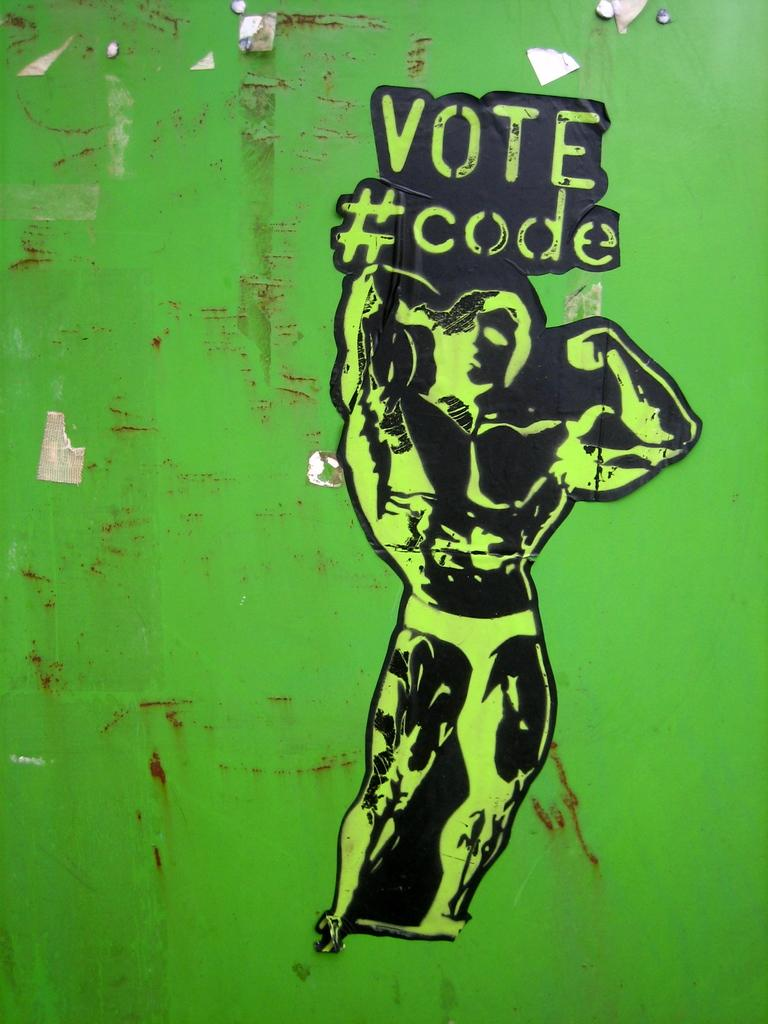What color is the wall in the image? The wall in the image is green. What is on the wall in the image? There is a sticker of a person on the wall and some text visible. What type of tray is being used to hold the spring in the image? There is no tray or spring present in the image. 